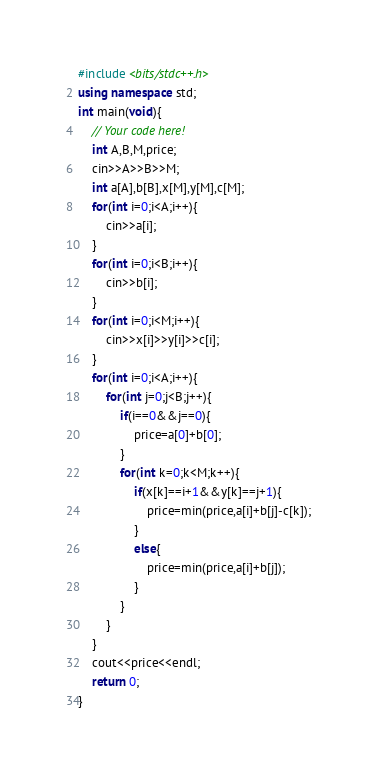<code> <loc_0><loc_0><loc_500><loc_500><_C++_>#include <bits/stdc++.h>
using namespace std;
int main(void){
    // Your code here!
    int A,B,M,price;
    cin>>A>>B>>M;
    int a[A],b[B],x[M],y[M],c[M];
    for(int i=0;i<A;i++){
        cin>>a[i];
    }
    for(int i=0;i<B;i++){
        cin>>b[i];
    }
    for(int i=0;i<M;i++){
        cin>>x[i]>>y[i]>>c[i];
    }
    for(int i=0;i<A;i++){
        for(int j=0;j<B;j++){
            if(i==0&&j==0){
                price=a[0]+b[0];
            }
            for(int k=0;k<M;k++){
                if(x[k]==i+1&&y[k]==j+1){
                    price=min(price,a[i]+b[j]-c[k]);
                }
                else{
                    price=min(price,a[i]+b[j]);
                }
            }
        }
    }
    cout<<price<<endl;
    return 0;
}
</code> 